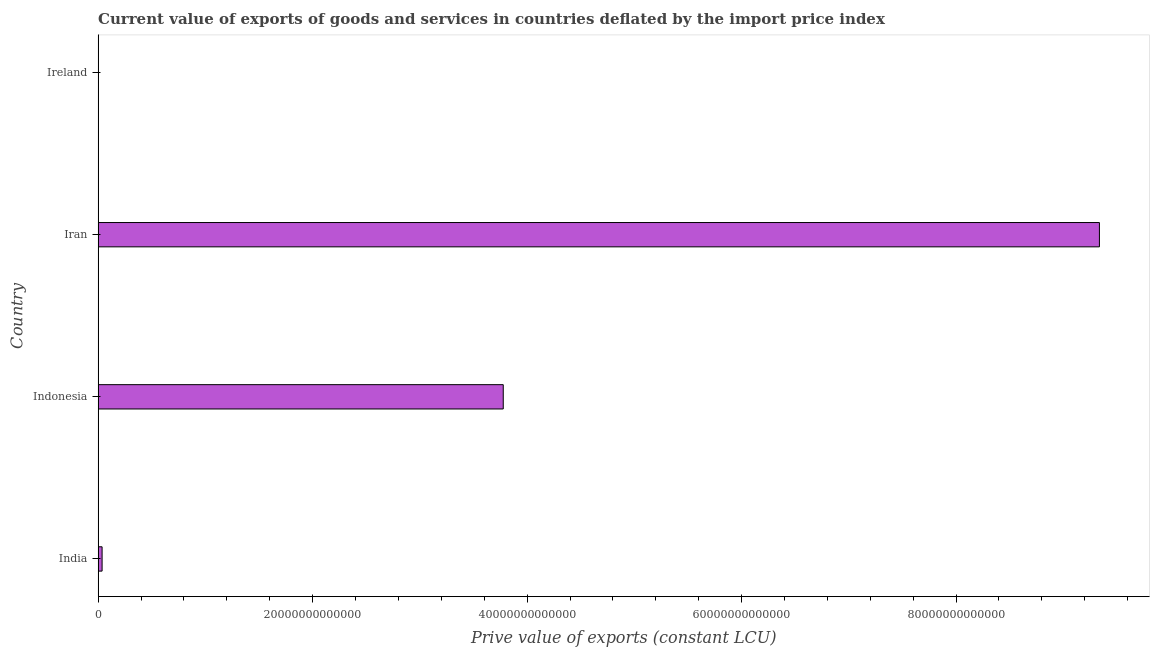Does the graph contain any zero values?
Provide a short and direct response. No. Does the graph contain grids?
Provide a short and direct response. No. What is the title of the graph?
Make the answer very short. Current value of exports of goods and services in countries deflated by the import price index. What is the label or title of the X-axis?
Make the answer very short. Prive value of exports (constant LCU). What is the label or title of the Y-axis?
Keep it short and to the point. Country. What is the price value of exports in India?
Offer a terse response. 3.71e+11. Across all countries, what is the maximum price value of exports?
Your answer should be very brief. 9.34e+13. Across all countries, what is the minimum price value of exports?
Ensure brevity in your answer.  6.13e+09. In which country was the price value of exports maximum?
Your answer should be compact. Iran. In which country was the price value of exports minimum?
Provide a succinct answer. Ireland. What is the sum of the price value of exports?
Provide a short and direct response. 1.32e+14. What is the difference between the price value of exports in Indonesia and Ireland?
Your response must be concise. 3.78e+13. What is the average price value of exports per country?
Ensure brevity in your answer.  3.29e+13. What is the median price value of exports?
Offer a terse response. 1.91e+13. In how many countries, is the price value of exports greater than 72000000000000 LCU?
Provide a short and direct response. 1. What is the ratio of the price value of exports in Indonesia to that in Ireland?
Give a very brief answer. 6163.29. Is the price value of exports in Indonesia less than that in Ireland?
Your answer should be compact. No. Is the difference between the price value of exports in Iran and Ireland greater than the difference between any two countries?
Give a very brief answer. Yes. What is the difference between the highest and the second highest price value of exports?
Your response must be concise. 5.56e+13. What is the difference between the highest and the lowest price value of exports?
Your response must be concise. 9.34e+13. Are all the bars in the graph horizontal?
Your answer should be very brief. Yes. What is the difference between two consecutive major ticks on the X-axis?
Your response must be concise. 2.00e+13. Are the values on the major ticks of X-axis written in scientific E-notation?
Make the answer very short. No. What is the Prive value of exports (constant LCU) in India?
Offer a terse response. 3.71e+11. What is the Prive value of exports (constant LCU) of Indonesia?
Provide a short and direct response. 3.78e+13. What is the Prive value of exports (constant LCU) in Iran?
Make the answer very short. 9.34e+13. What is the Prive value of exports (constant LCU) of Ireland?
Ensure brevity in your answer.  6.13e+09. What is the difference between the Prive value of exports (constant LCU) in India and Indonesia?
Provide a short and direct response. -3.74e+13. What is the difference between the Prive value of exports (constant LCU) in India and Iran?
Provide a succinct answer. -9.30e+13. What is the difference between the Prive value of exports (constant LCU) in India and Ireland?
Your answer should be compact. 3.65e+11. What is the difference between the Prive value of exports (constant LCU) in Indonesia and Iran?
Your response must be concise. -5.56e+13. What is the difference between the Prive value of exports (constant LCU) in Indonesia and Ireland?
Your response must be concise. 3.78e+13. What is the difference between the Prive value of exports (constant LCU) in Iran and Ireland?
Provide a succinct answer. 9.34e+13. What is the ratio of the Prive value of exports (constant LCU) in India to that in Indonesia?
Offer a terse response. 0.01. What is the ratio of the Prive value of exports (constant LCU) in India to that in Iran?
Provide a succinct answer. 0. What is the ratio of the Prive value of exports (constant LCU) in India to that in Ireland?
Your response must be concise. 60.6. What is the ratio of the Prive value of exports (constant LCU) in Indonesia to that in Iran?
Offer a very short reply. 0.41. What is the ratio of the Prive value of exports (constant LCU) in Indonesia to that in Ireland?
Your answer should be compact. 6163.29. What is the ratio of the Prive value of exports (constant LCU) in Iran to that in Ireland?
Offer a very short reply. 1.52e+04. 